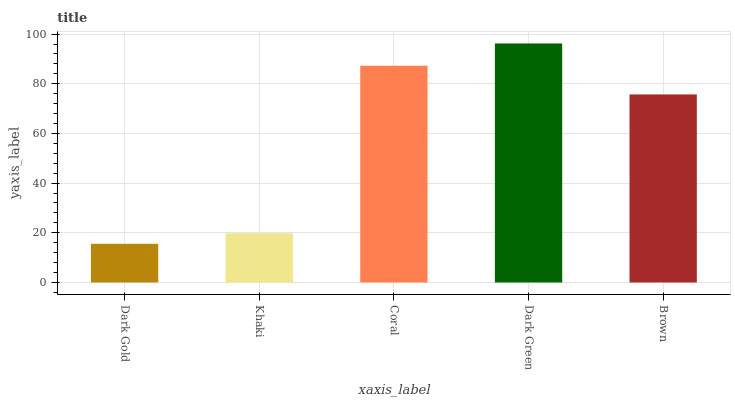Is Dark Gold the minimum?
Answer yes or no. Yes. Is Dark Green the maximum?
Answer yes or no. Yes. Is Khaki the minimum?
Answer yes or no. No. Is Khaki the maximum?
Answer yes or no. No. Is Khaki greater than Dark Gold?
Answer yes or no. Yes. Is Dark Gold less than Khaki?
Answer yes or no. Yes. Is Dark Gold greater than Khaki?
Answer yes or no. No. Is Khaki less than Dark Gold?
Answer yes or no. No. Is Brown the high median?
Answer yes or no. Yes. Is Brown the low median?
Answer yes or no. Yes. Is Dark Gold the high median?
Answer yes or no. No. Is Dark Green the low median?
Answer yes or no. No. 